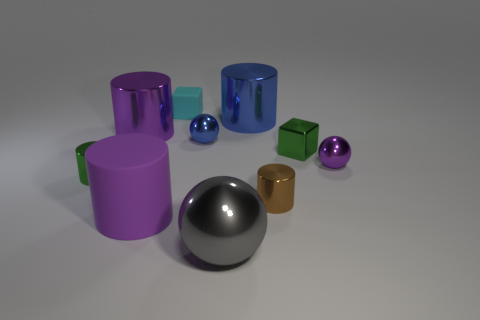What shape is the big thing that is the same color as the matte cylinder?
Offer a terse response. Cylinder. Are there more purple rubber objects that are behind the big blue object than big red shiny objects?
Keep it short and to the point. No. What is the size of the blue sphere that is made of the same material as the green cube?
Offer a very short reply. Small. Are there any purple shiny things in front of the tiny cyan matte thing?
Your answer should be compact. Yes. Is the large gray thing the same shape as the small blue metallic object?
Offer a terse response. Yes. There is a rubber cube behind the large metal thing in front of the tiny green object that is right of the purple metal cylinder; what is its size?
Keep it short and to the point. Small. What material is the cyan cube?
Give a very brief answer. Rubber. The ball that is the same color as the large matte thing is what size?
Your answer should be very brief. Small. There is a small blue object; is its shape the same as the tiny object that is on the left side of the cyan block?
Provide a short and direct response. No. What material is the small cube that is behind the tiny shiny sphere to the left of the tiny cylinder that is on the right side of the big gray object?
Provide a succinct answer. Rubber. 